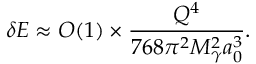Convert formula to latex. <formula><loc_0><loc_0><loc_500><loc_500>\delta E \approx O ( 1 ) \times \frac { Q ^ { 4 } } { 7 6 8 \pi ^ { 2 } M _ { \gamma } ^ { 2 } a _ { 0 } ^ { 3 } } .</formula> 